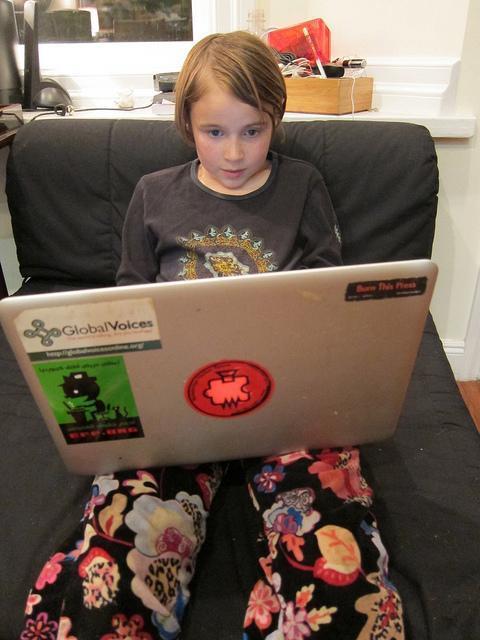How many laptops are there?
Give a very brief answer. 1. 